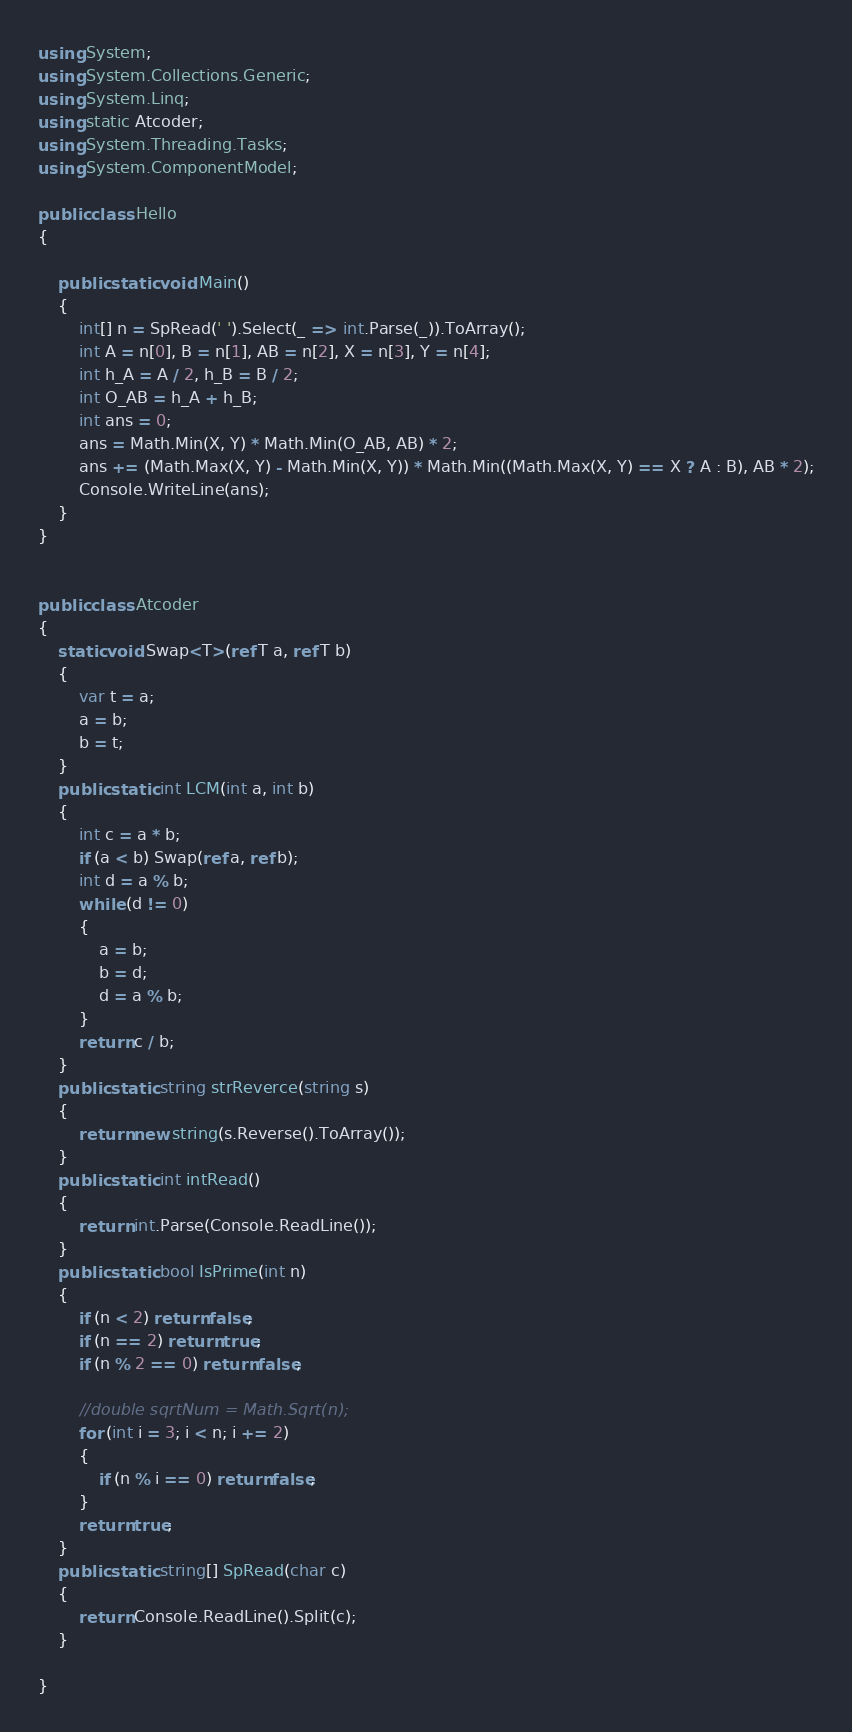Convert code to text. <code><loc_0><loc_0><loc_500><loc_500><_C#_>using System;
using System.Collections.Generic;
using System.Linq;
using static Atcoder;
using System.Threading.Tasks;
using System.ComponentModel;

public class Hello
{

    public static void Main()
    {
        int[] n = SpRead(' ').Select(_ => int.Parse(_)).ToArray();
        int A = n[0], B = n[1], AB = n[2], X = n[3], Y = n[4];
        int h_A = A / 2, h_B = B / 2;
        int O_AB = h_A + h_B;
        int ans = 0;
        ans = Math.Min(X, Y) * Math.Min(O_AB, AB) * 2;
        ans += (Math.Max(X, Y) - Math.Min(X, Y)) * Math.Min((Math.Max(X, Y) == X ? A : B), AB * 2);
        Console.WriteLine(ans);
    }
}


public class Atcoder
{
    static void Swap<T>(ref T a, ref T b)
    {
        var t = a;
        a = b;
        b = t;
    }
    public static int LCM(int a, int b)
    {
        int c = a * b;
        if (a < b) Swap(ref a, ref b);
        int d = a % b;
        while (d != 0)
        {
            a = b;
            b = d;
            d = a % b;
        }
        return c / b;
    }
    public static string strReverce(string s)
    {
        return new string(s.Reverse().ToArray());
    }
    public static int intRead()
    {
        return int.Parse(Console.ReadLine());
    }
    public static bool IsPrime(int n)
    {
        if (n < 2) return false;
        if (n == 2) return true;
        if (n % 2 == 0) return false;

        //double sqrtNum = Math.Sqrt(n);
        for (int i = 3; i < n; i += 2)
        {
            if (n % i == 0) return false;
        }
        return true;
    }
    public static string[] SpRead(char c)
    {
        return Console.ReadLine().Split(c);
    }

}
</code> 